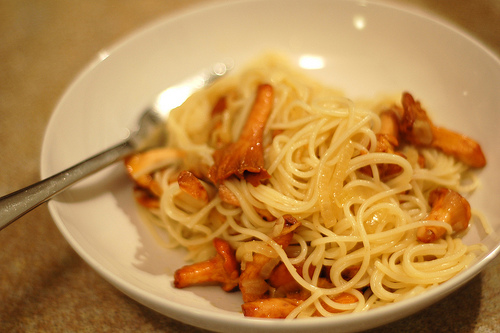<image>
Is there a food on the bowel? Yes. Looking at the image, I can see the food is positioned on top of the bowel, with the bowel providing support. 